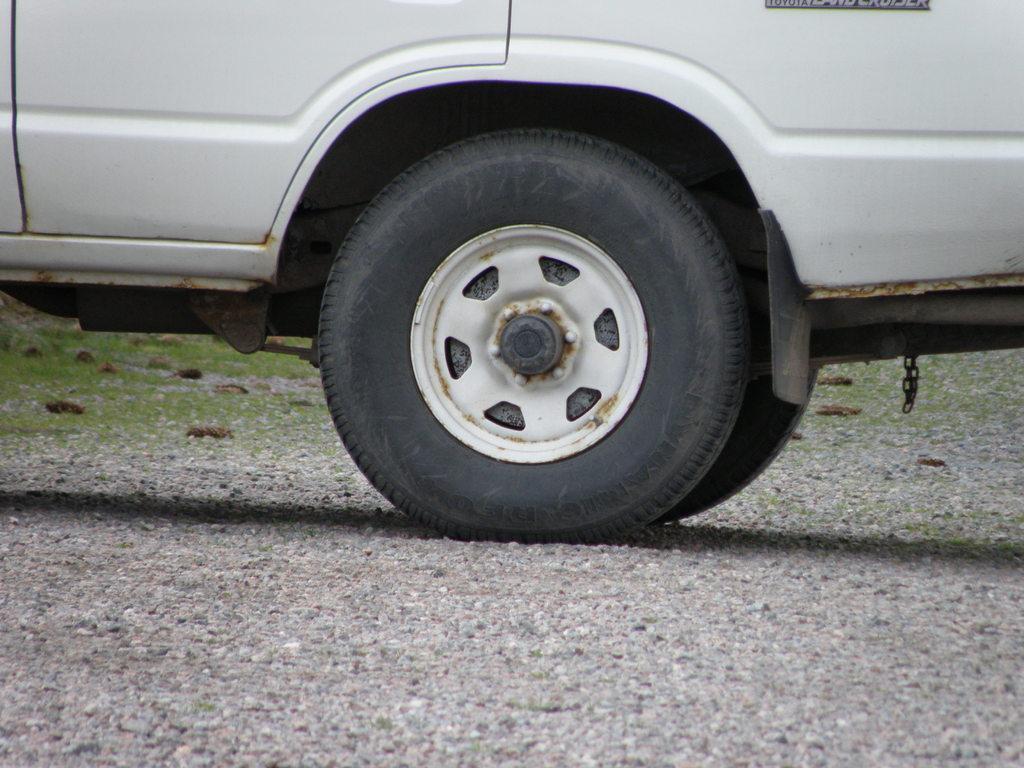Could you give a brief overview of what you see in this image? In this image there is a vehicle having tires. The vehicle is on the land having rocks and grass. 